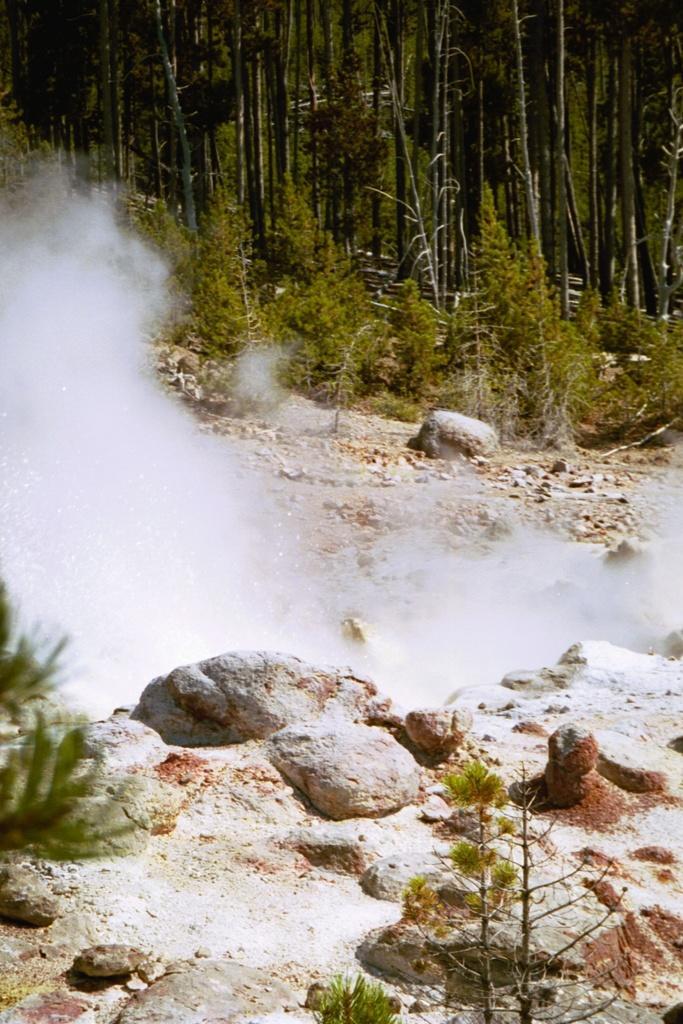Can you describe this image briefly? In the picture we can see a surface with some stones and plants and beside it, we can see smoke and beside it, we can see a path with some stones, plants and trees. 